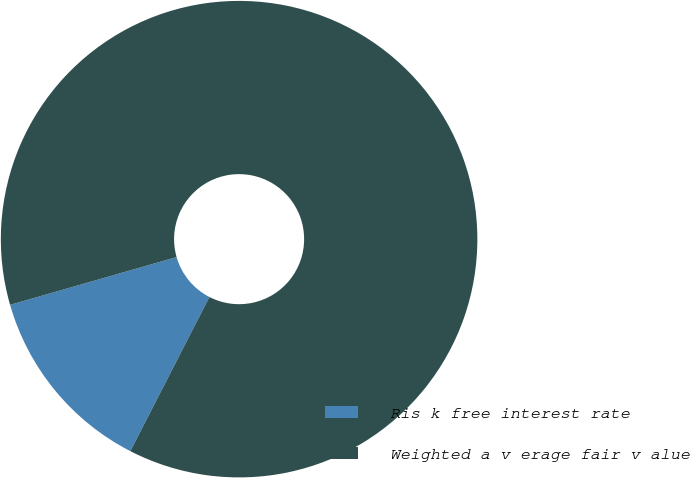Convert chart to OTSL. <chart><loc_0><loc_0><loc_500><loc_500><pie_chart><fcel>Ris k free interest rate<fcel>Weighted a v erage fair v alue<nl><fcel>13.01%<fcel>86.99%<nl></chart> 